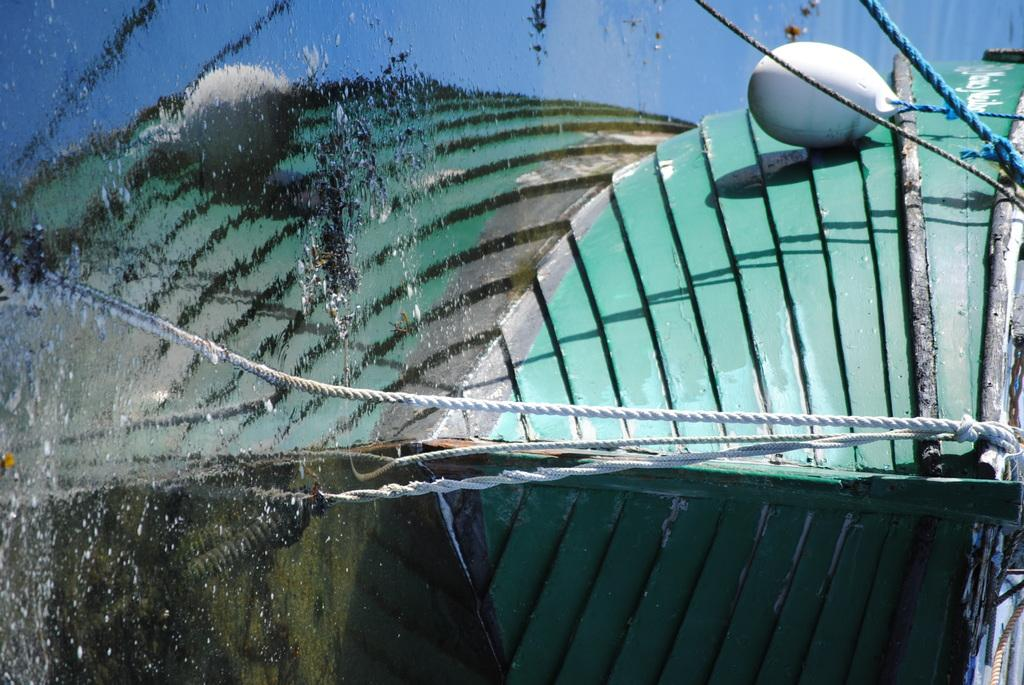What is the main subject of the image? The main subject of the image is a boat. Where is the boat located? The boat is on the water. What else can be seen in the image besides the boat? There are tapes in the image. What type of organization is responsible for the holiday depicted in the image? There is no holiday depicted in the image, as it features a boat on the water and tapes. 